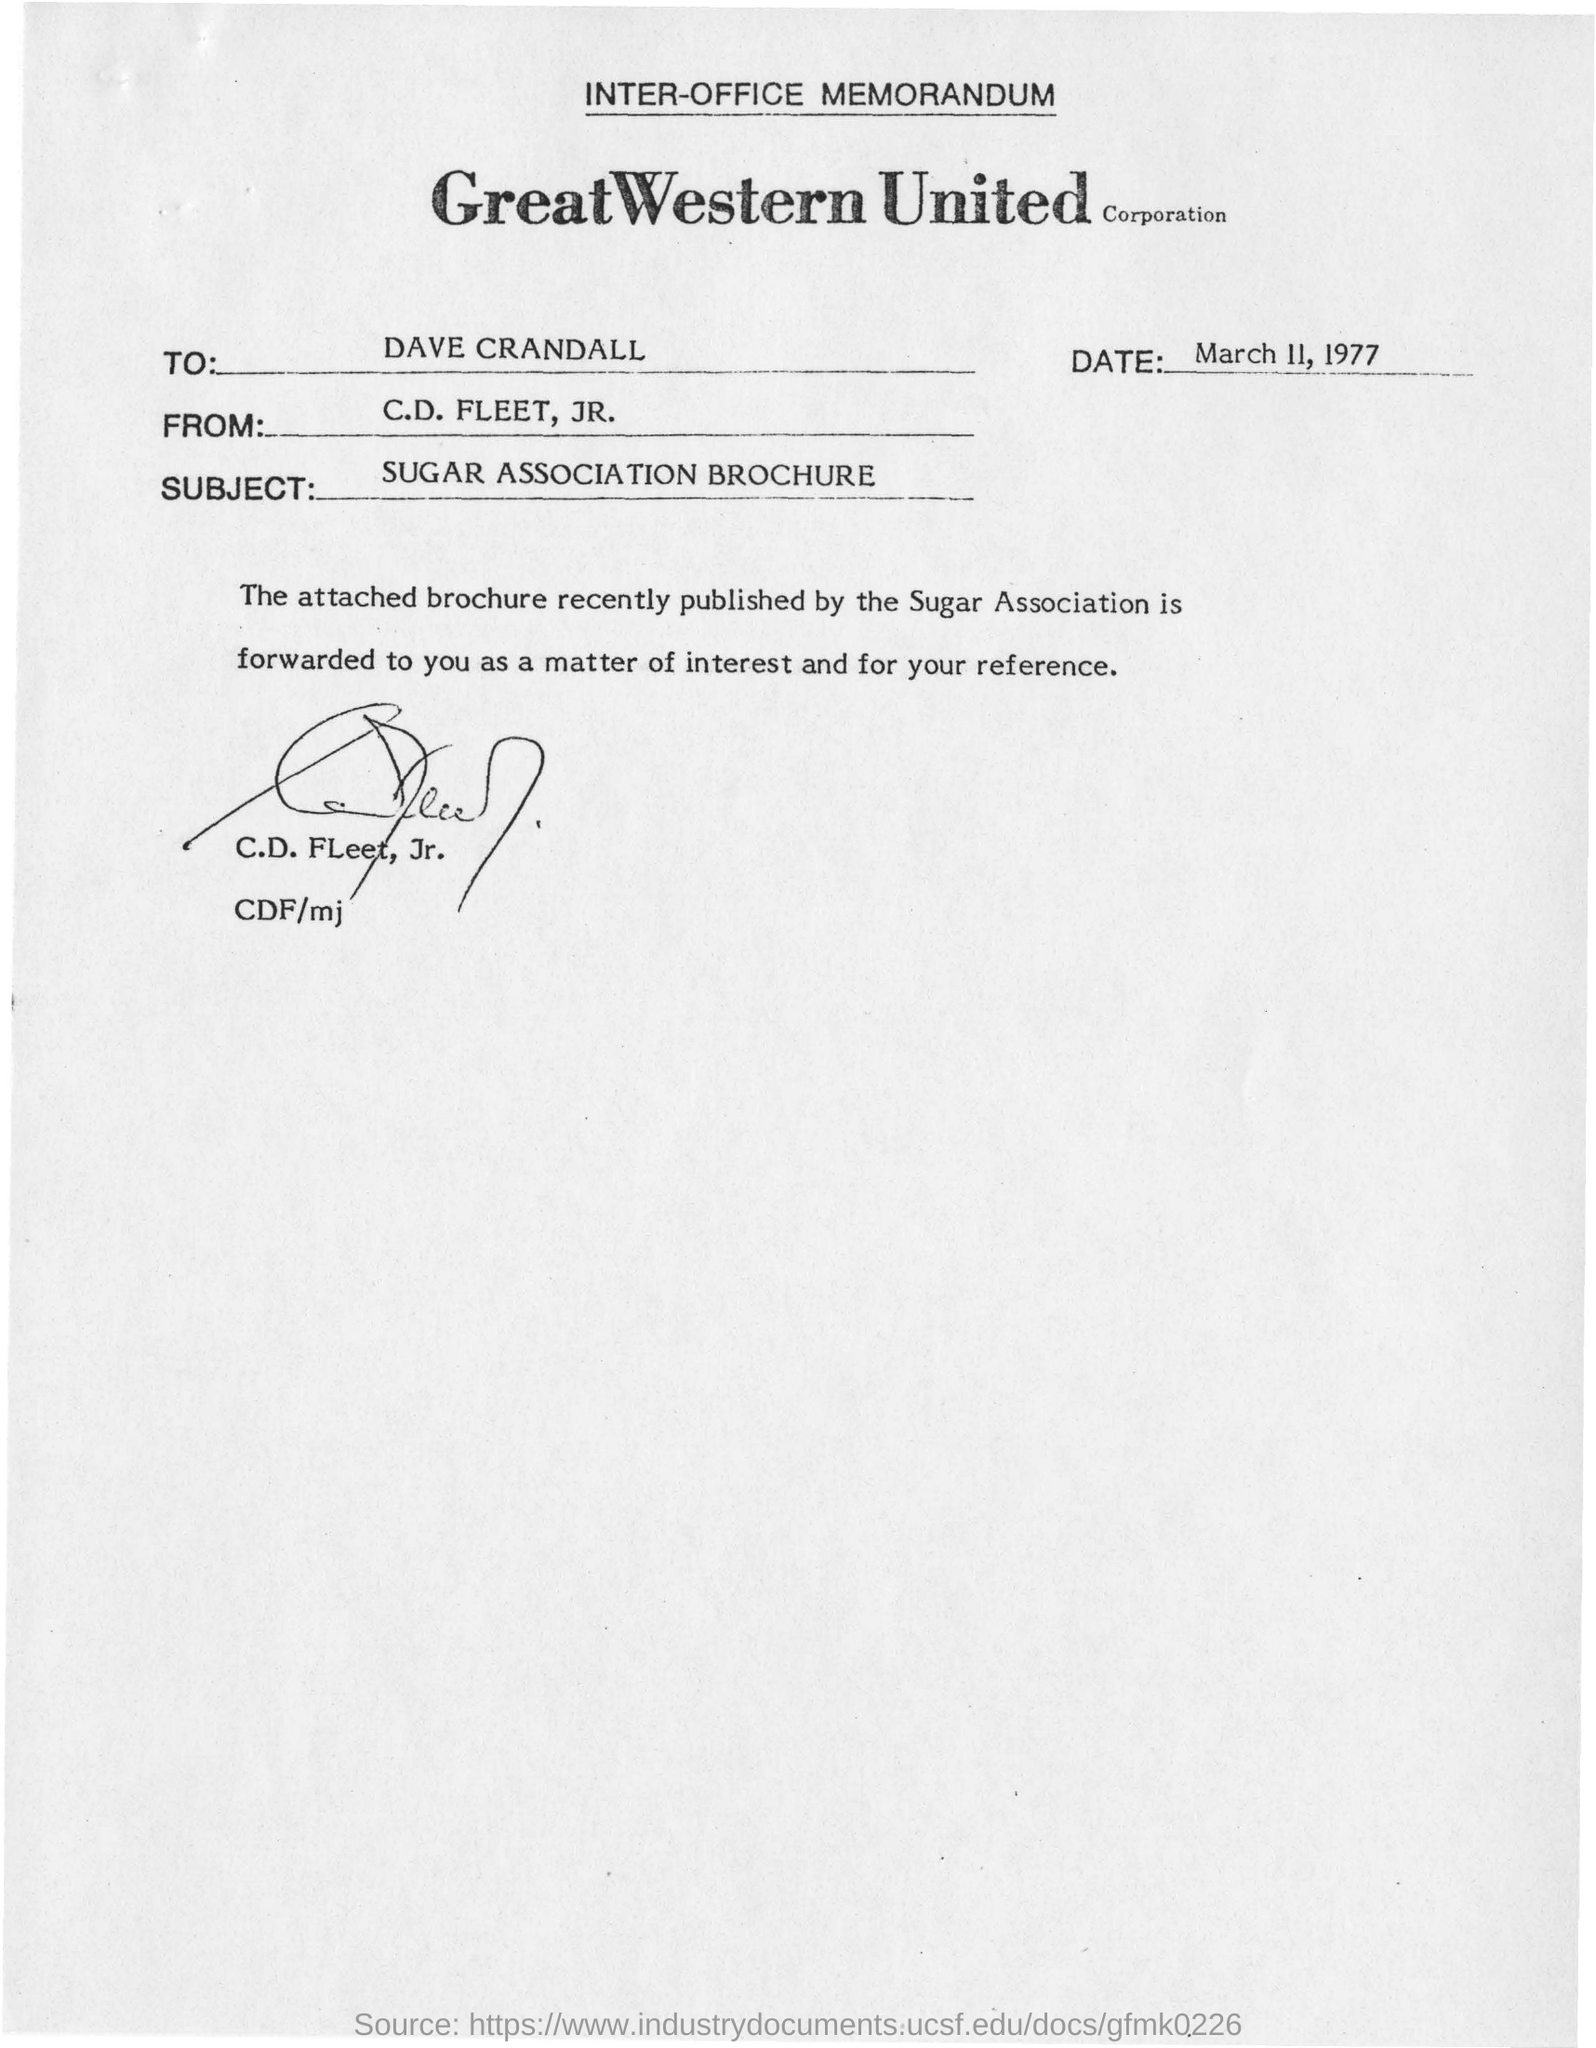From whom the memorandum is sent
Keep it short and to the point. C.D. Fleet, JR. To Whom is this memorandum addressed to?
Offer a very short reply. Dave Crandall. 